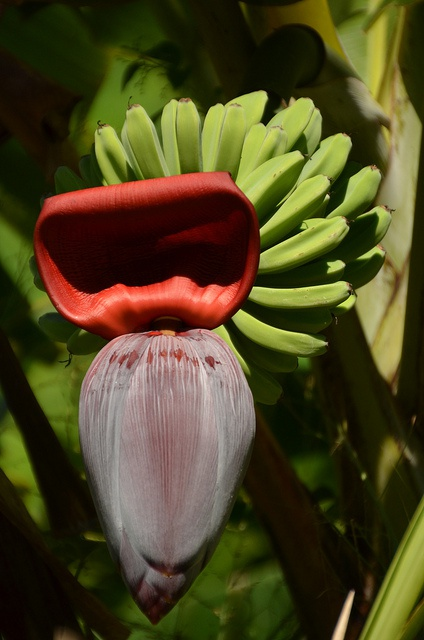Describe the objects in this image and their specific colors. I can see a banana in black, olive, and khaki tones in this image. 